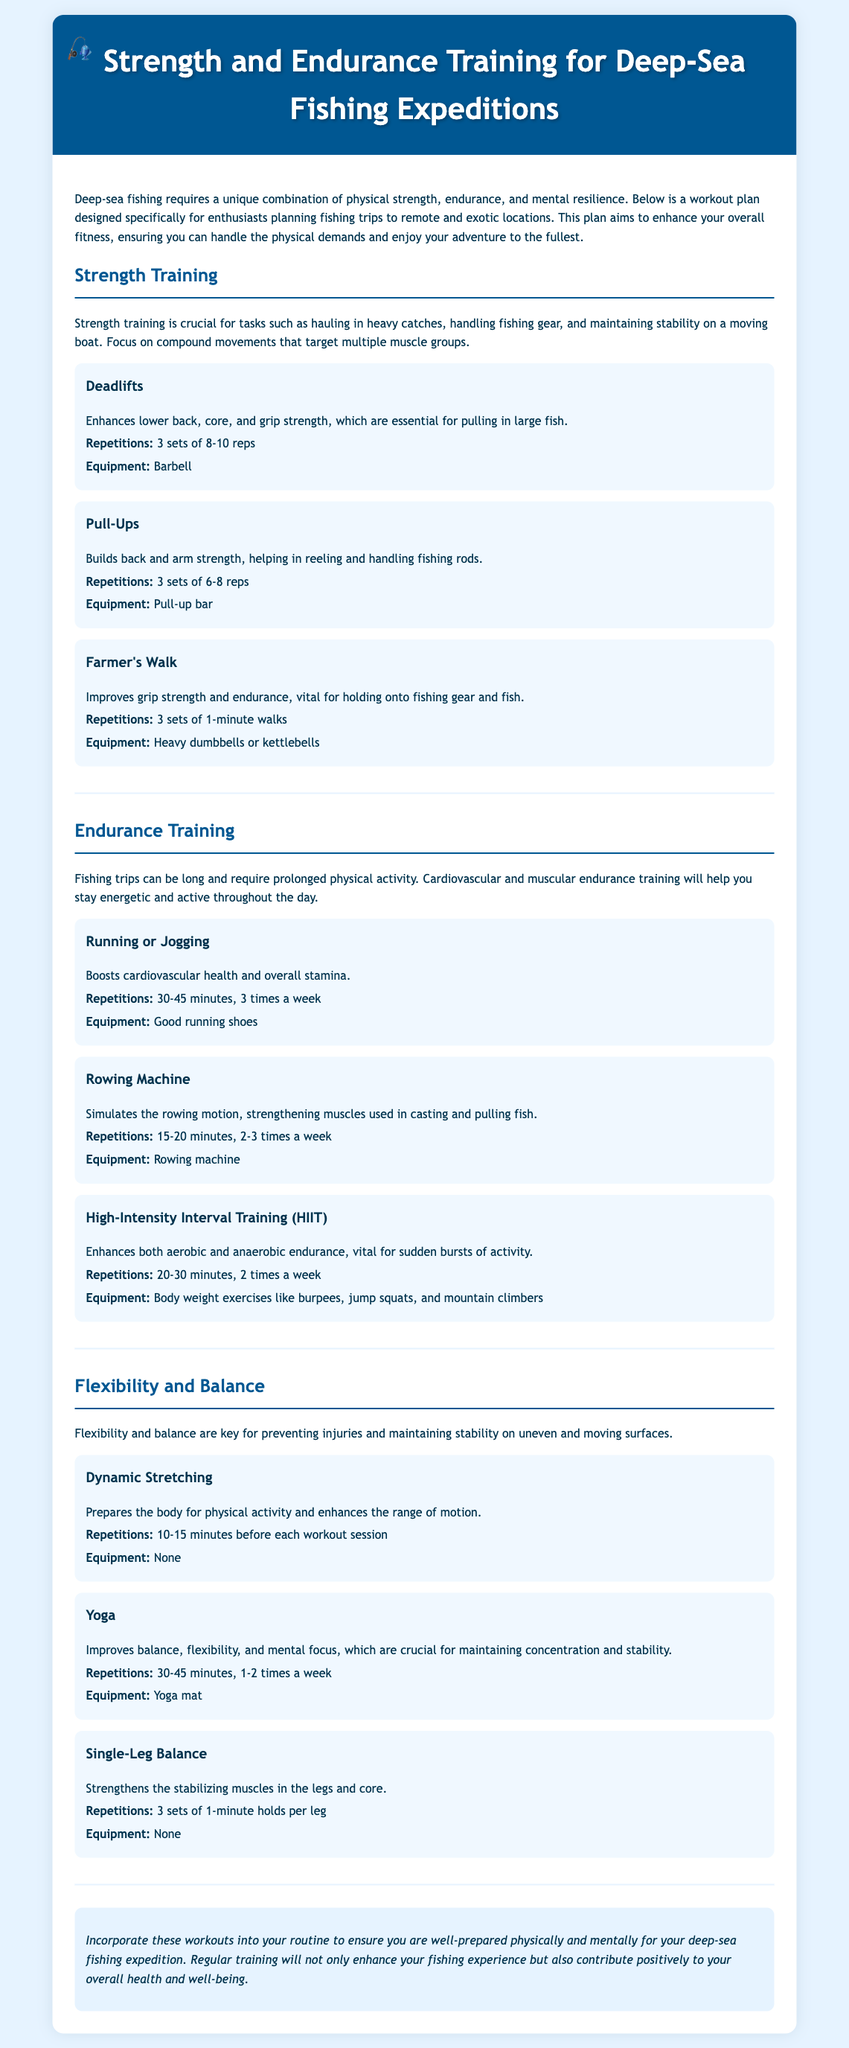What is the main purpose of the workout plan? The document states that the workout plan is designed to enhance overall fitness for deep-sea fishing expeditions.
Answer: Enhance overall fitness How many sets of pull-ups are recommended? The document specifies that pull-ups should be done in 3 sets of 6-8 reps.
Answer: 3 sets of 6-8 reps What type of training is emphasized for preventing injuries? The document highlights flexibility and balance training as key for preventing injuries.
Answer: Flexibility and balance What equipment is required for deadlifts? The workout plan indicates that a barbell is needed for deadlifts.
Answer: Barbell How often should one perform HIIT workouts? The text suggests doing HIIT workouts 2 times a week.
Answer: 2 times a week What exercise enhances grip strength vital for fishing? The workout plan mentions Farmer's Walk as an exercise to improve grip strength.
Answer: Farmer's Walk What is recommended for cardiovascular health? The document recommends running or jogging for cardiovascular health.
Answer: Running or jogging How long should dynamic stretching be performed before workouts? The plan advises performing dynamic stretching for 10-15 minutes before each workout session.
Answer: 10-15 minutes What exercise improves mental focus, as per the document? The document states that yoga improves mental focus.
Answer: Yoga 